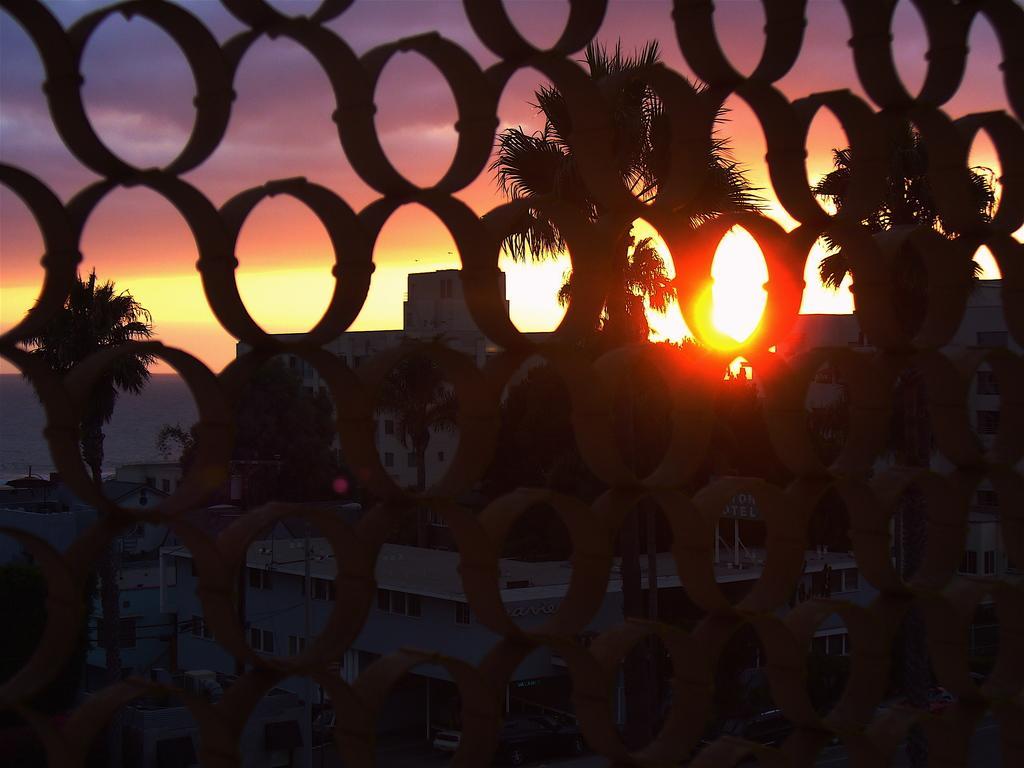Please provide a concise description of this image. Through this girl we can see trees, buildings, sky, board and sunlight. 